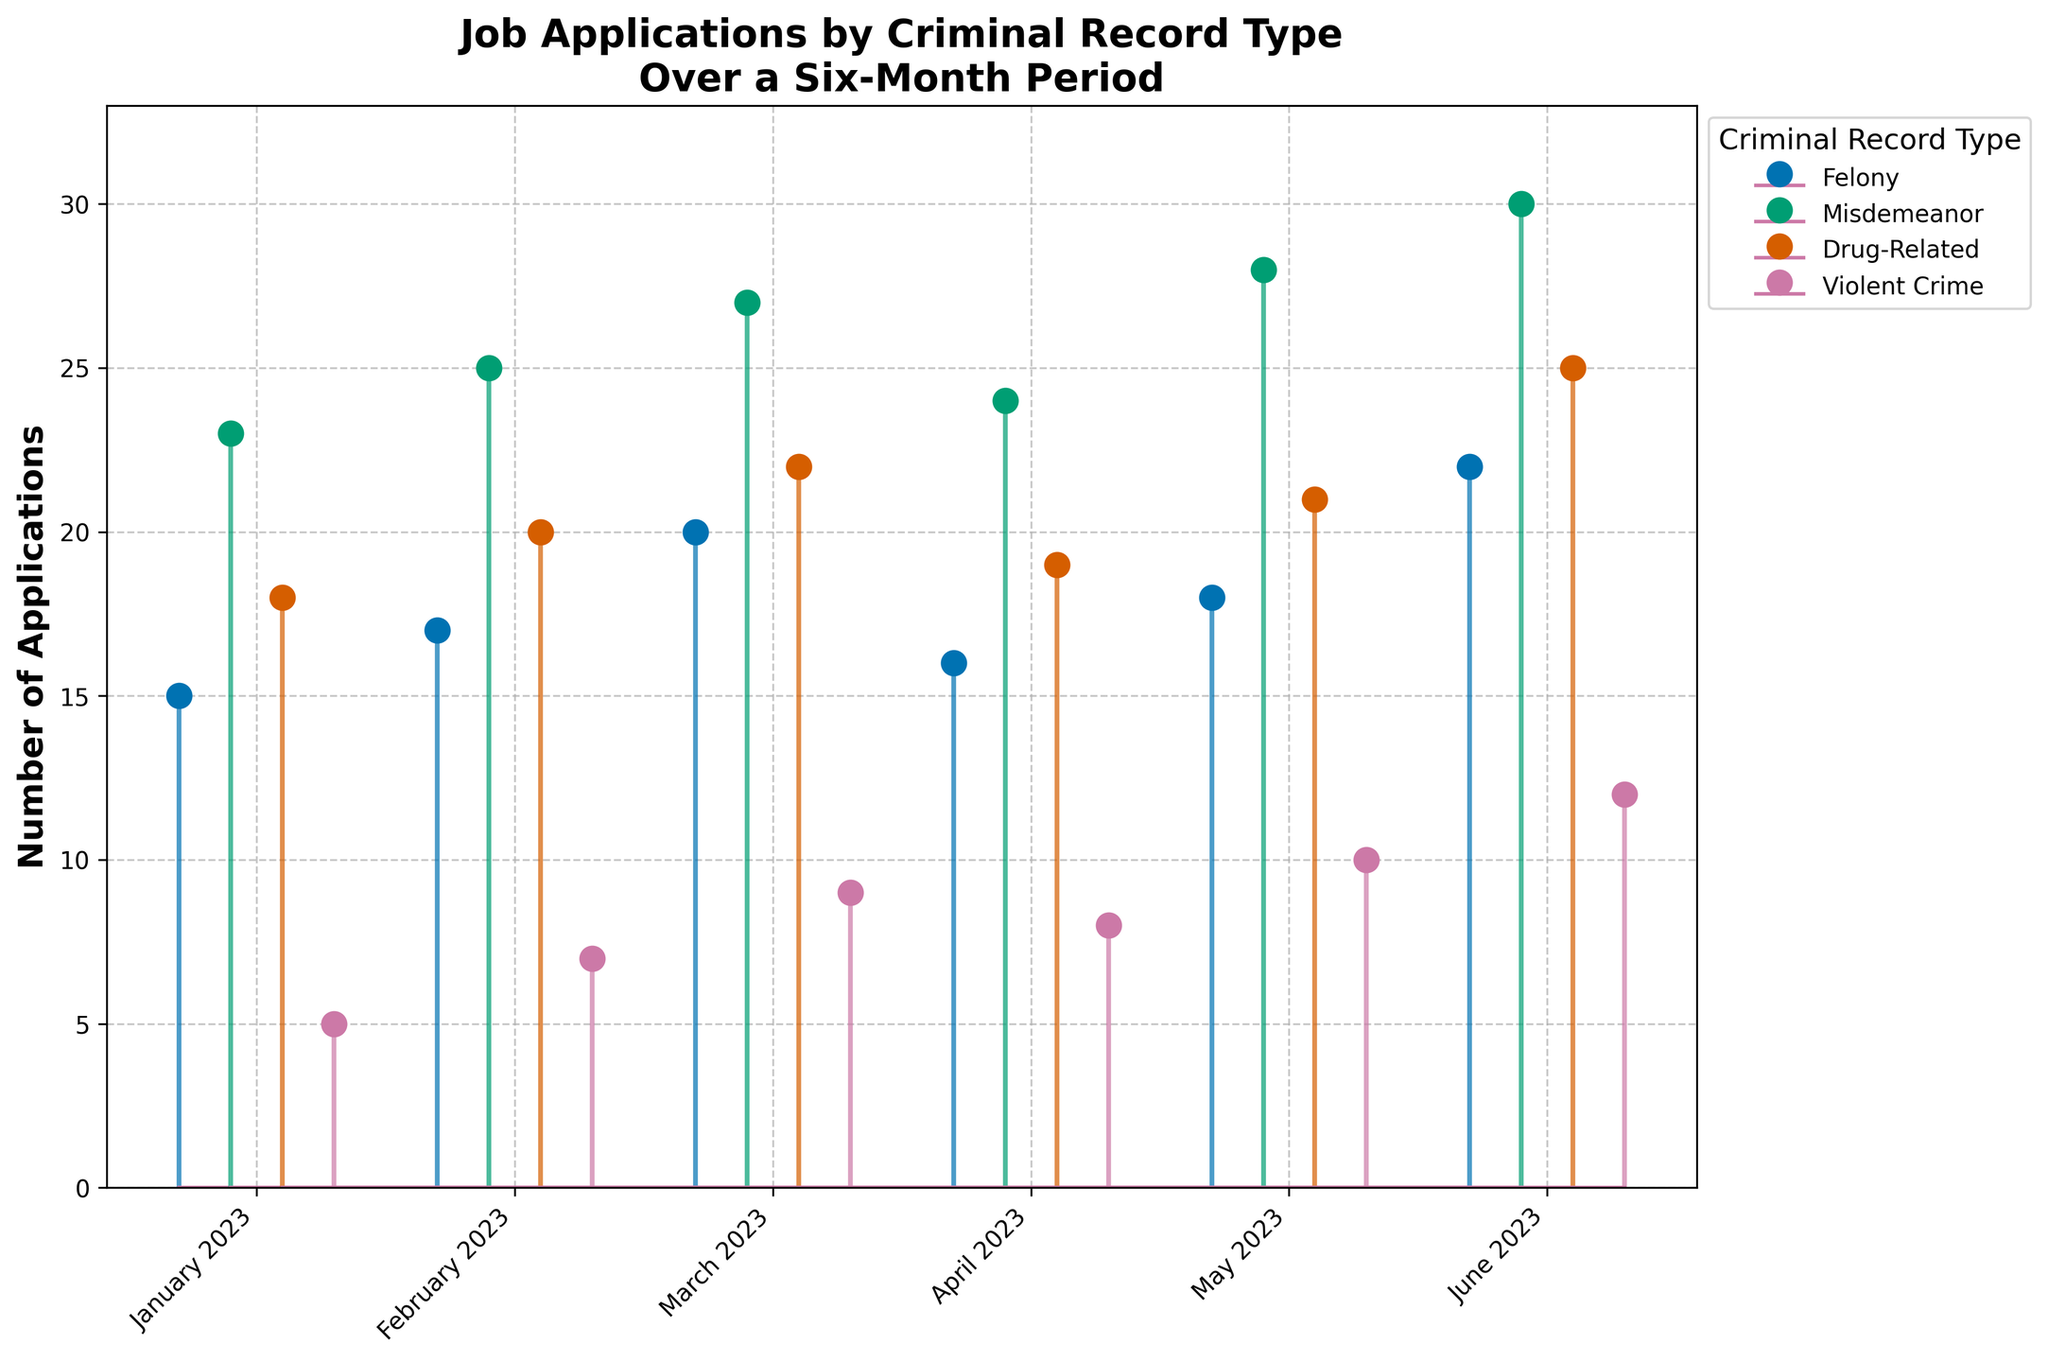What is the title of the figure? The title of the figure is displayed at the top and gives an overview of the data being presented. In this case, it describes the type of data (Job Applications) and the categories (Criminal Record Type) over a specified period (Six Months).
Answer: Job Applications by Criminal Record Type Over a Six-Month Period Which month had the highest number of felony applications? By examining the heights of the stems corresponding to felony applications, the tallest one indicates the highest number. For felony applications, the stem in June is the tallest.
Answer: June How many applications were there for violent crime in March? Locate the stem corresponding to violent crime in March. The number at the top of this stem represents the number of applications.
Answer: 9 What is the total number of misdemeanor applications over the six months? Add up the number of misdemeanor applications for each month: January (23), February (25), March (27), April (24), May (28), June (30). So the total is 23 + 25 + 27 + 24 + 28 + 30.
Answer: 157 How did the number of drug-related applications change from January to June? Identify the drug-related application numbers for January (18) and June (25) and calculate the difference. The increase from 18 to 25 indicates a rise in applications.
Answer: Increased by 7 Which criminal record type had the smallest increase in applications from January to June? Calculate the difference between January and June for each criminal record type:
- Felony: 22 - 15 = 7
- Misdemeanor: 30 - 23 = 7
- Drug-Related: 25 - 18 = 7
- Violent Crime: 12 - 5 = 7
Here, all types increased by the same amount, indicating no unique smallest increase.
Answer: All types increased by 7 What is the average number of applications for violent crimes over the six months? Add the numbers for each month (5, 7, 9, 8, 10, 12) and then divide by the number of months (6). (5 + 7 + 9 + 8 + 10 + 12) / 6 = 51 / 6.
Answer: 8.5 In which months did misdemeanor applications increase consecutively? Check the numbers for misdemeanors month by month to see if each month is higher than the previous. January (23), February (25), March (27), April (24), May (28), June (30) shows consecutive increases except from March to April.
Answer: January to March, May to June Which type of criminal record category had the highest variability in applications over the six months? Variability can be measured by the range (difference between maximum and minimum values). Calculate this for each type:
- Felony: 22 - 15 = 7
- Misdemeanor: 30 - 23 = 7
- Drug-Related: 25 - 18 = 7
- Violent Crime: 12 - 5 = 7
Here, all categories show the same variability in terms of the range of applications.
Answer: All types How many total applications were there in April across all criminal record types? Add the application numbers for April for each type: Felony (16), Misdemeanor (24), Drug-Related (19), Violent Crime (8). So, 16 + 24 + 19 + 8.
Answer: 67 